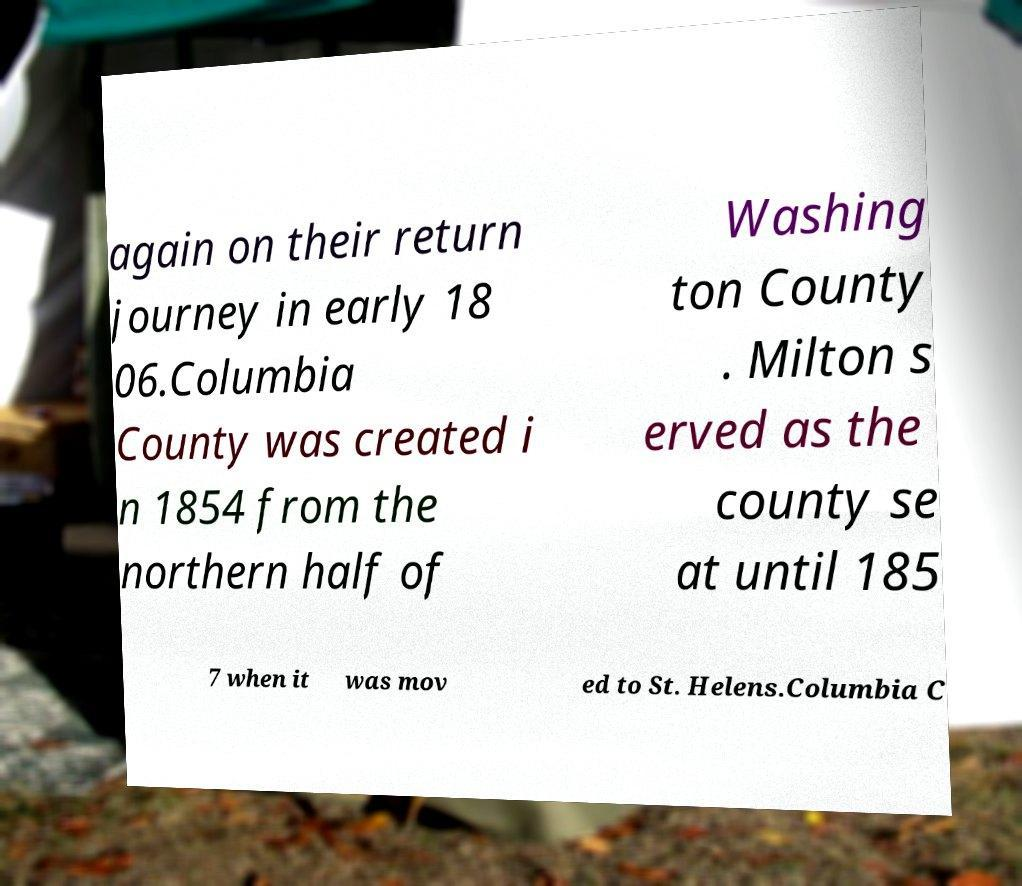For documentation purposes, I need the text within this image transcribed. Could you provide that? again on their return journey in early 18 06.Columbia County was created i n 1854 from the northern half of Washing ton County . Milton s erved as the county se at until 185 7 when it was mov ed to St. Helens.Columbia C 